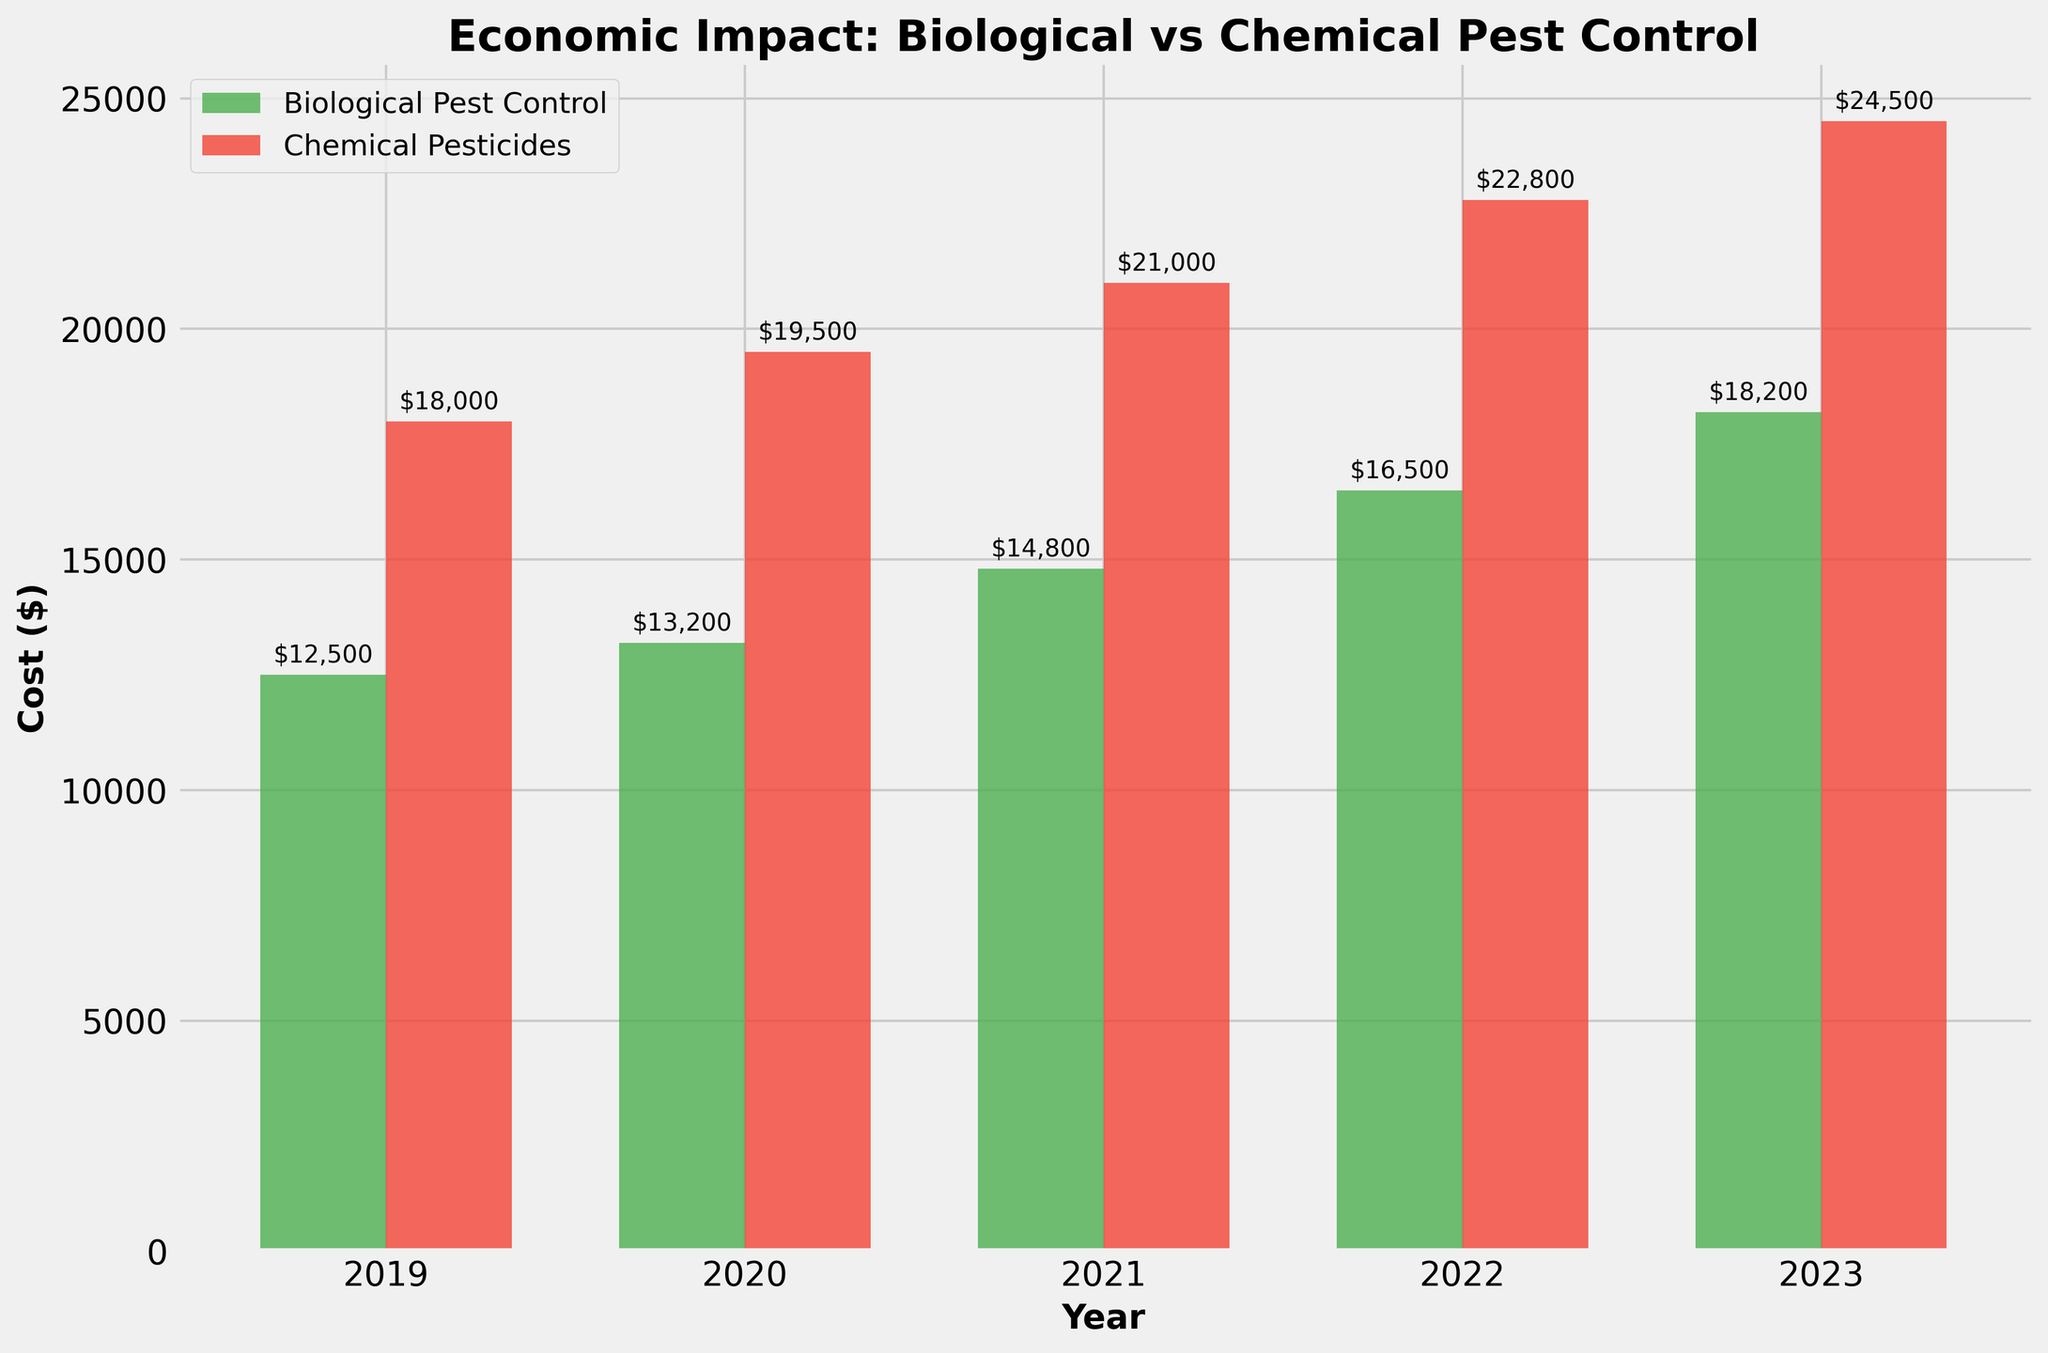What's the lowest cost recorded for Biological Pest Control? The bar labeled "2019" for "Biological Pest Control" is the shortest, representing the lowest cost. Eyeballing the height, it is about $12,500.
Answer: $12,500 What's the difference in cost between Chemical Pesticides and Biological Pest Control in 2023? The 2023 bar for Chemical Pesticides is the highest, approximately $24,500, and the 2023 bar for Biological Pest Control is about $18,200. Subtract the two values: $24,500 - $18,200 = $6,300.
Answer: $6,300 Which year shows the greatest improvement in cost for Biological Pest Control compared to the previous year? Calculate the year-over-year differences for Biological Pest Control: $13,200 - $12,500 = $700 for 2020, $14,800 - $13,200 = $1,600 for 2021, $16,500 - $14,800 = $1,700 for 2022, and $18,200 - $16,500 = $1,700 for 2023. The year with the greatest improvement is 2022 or 2023, both having an increase of $1,700.
Answer: 2022 or 2023 Which pest control method generally had a higher cost each year? By comparing the height of the bars for each year, the red bars (Chemical Pesticides) are always taller than the green bars (Biological Pest Control).
Answer: Chemical Pesticides How much does the cost of Biological Pest Control in 2022 exceed that in 2019? The cost in 2022 is approximately $16,500, and in 2019, it is about $12,500. Subtracting these values: $16,500 - $12,500 = $4,000.
Answer: $4,000 What's the average cost of Chemical Pesticides over the 5-year period? Sum the costs for Chemical Pesticides over the 5 years: $18,000 + $19,500 + $21,000 + $22,800 + $24,500 = $105,800. Then, divide by 5: $105,800 / 5 = $21,160.
Answer: $21,160 How does the total cost of using Biological Pest Control compare to using Chemical Pesticides over the 5-year period? First, calculate the total cost for each: $12,500 + $13,200 + $14,800 + $16,500 + $18,200 = $75,200 for Biological Pest Control and $18,000 + $19,500 + $21,000 + $22,800 + $24,500 = $105,800 for Chemical Pesticides. Comparing the two: $105,800 - $75,200 = $30,600.
Answer: Chemical Pesticides are $30,600 more expensive Which year had the smallest difference between the costs of the two pest control methods? Subtract the costs of Biological Pest Control from Chemical Pesticides for each year: 2019: $18,000 - $12,500 = $5,500, 2020: $19,500 - $13,200 = $6,300, 2021: $21,000 - $14,800 = $6,200, 2022: $22,800 - $16,500 = $6,300, 2023: $24,500 - $18,200 = $6,300. The year 2019 has the smallest difference of $5,500.
Answer: 2019 